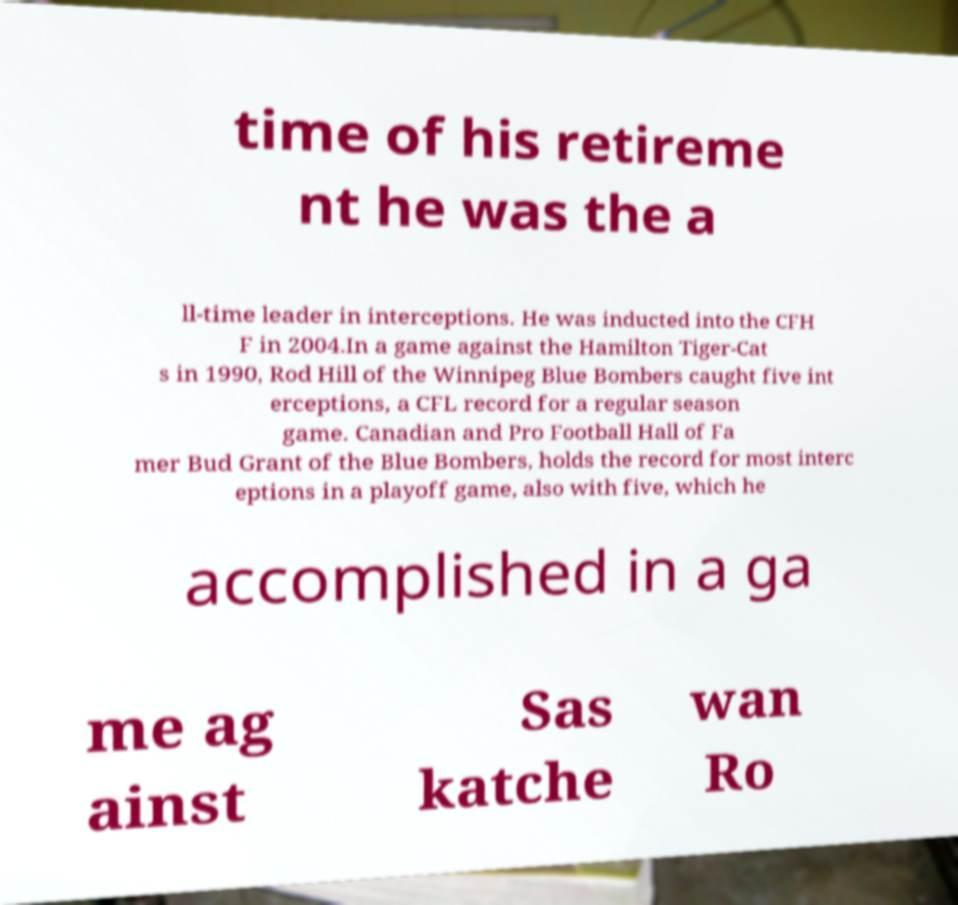For documentation purposes, I need the text within this image transcribed. Could you provide that? time of his retireme nt he was the a ll-time leader in interceptions. He was inducted into the CFH F in 2004.In a game against the Hamilton Tiger-Cat s in 1990, Rod Hill of the Winnipeg Blue Bombers caught five int erceptions, a CFL record for a regular season game. Canadian and Pro Football Hall of Fa mer Bud Grant of the Blue Bombers, holds the record for most interc eptions in a playoff game, also with five, which he accomplished in a ga me ag ainst Sas katche wan Ro 